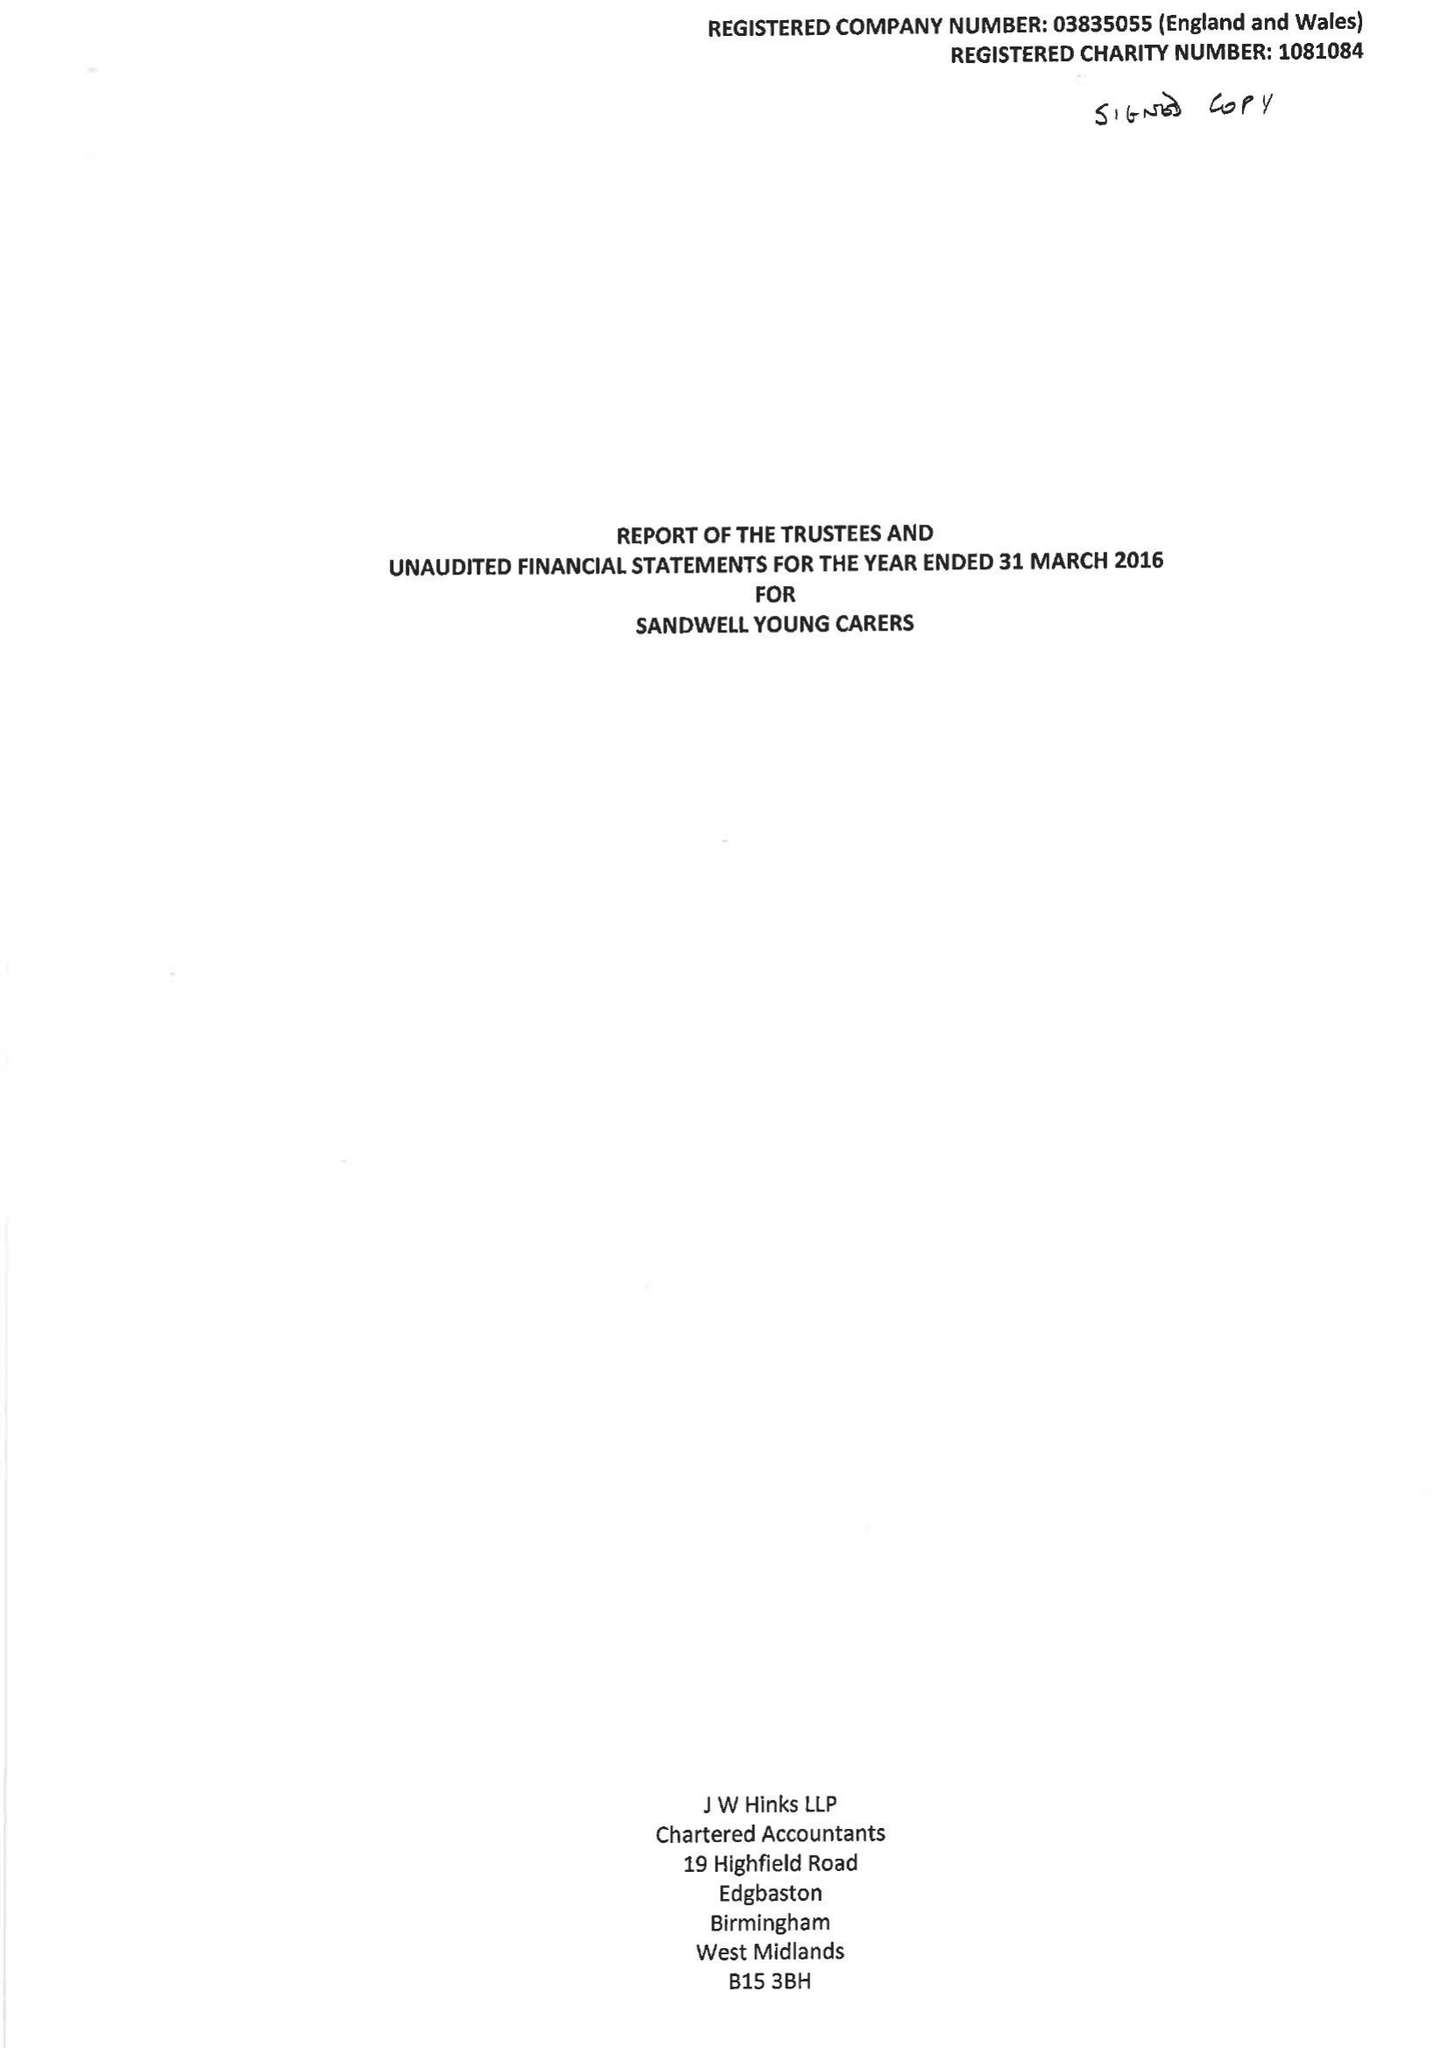What is the value for the spending_annually_in_british_pounds?
Answer the question using a single word or phrase. 255791.00 